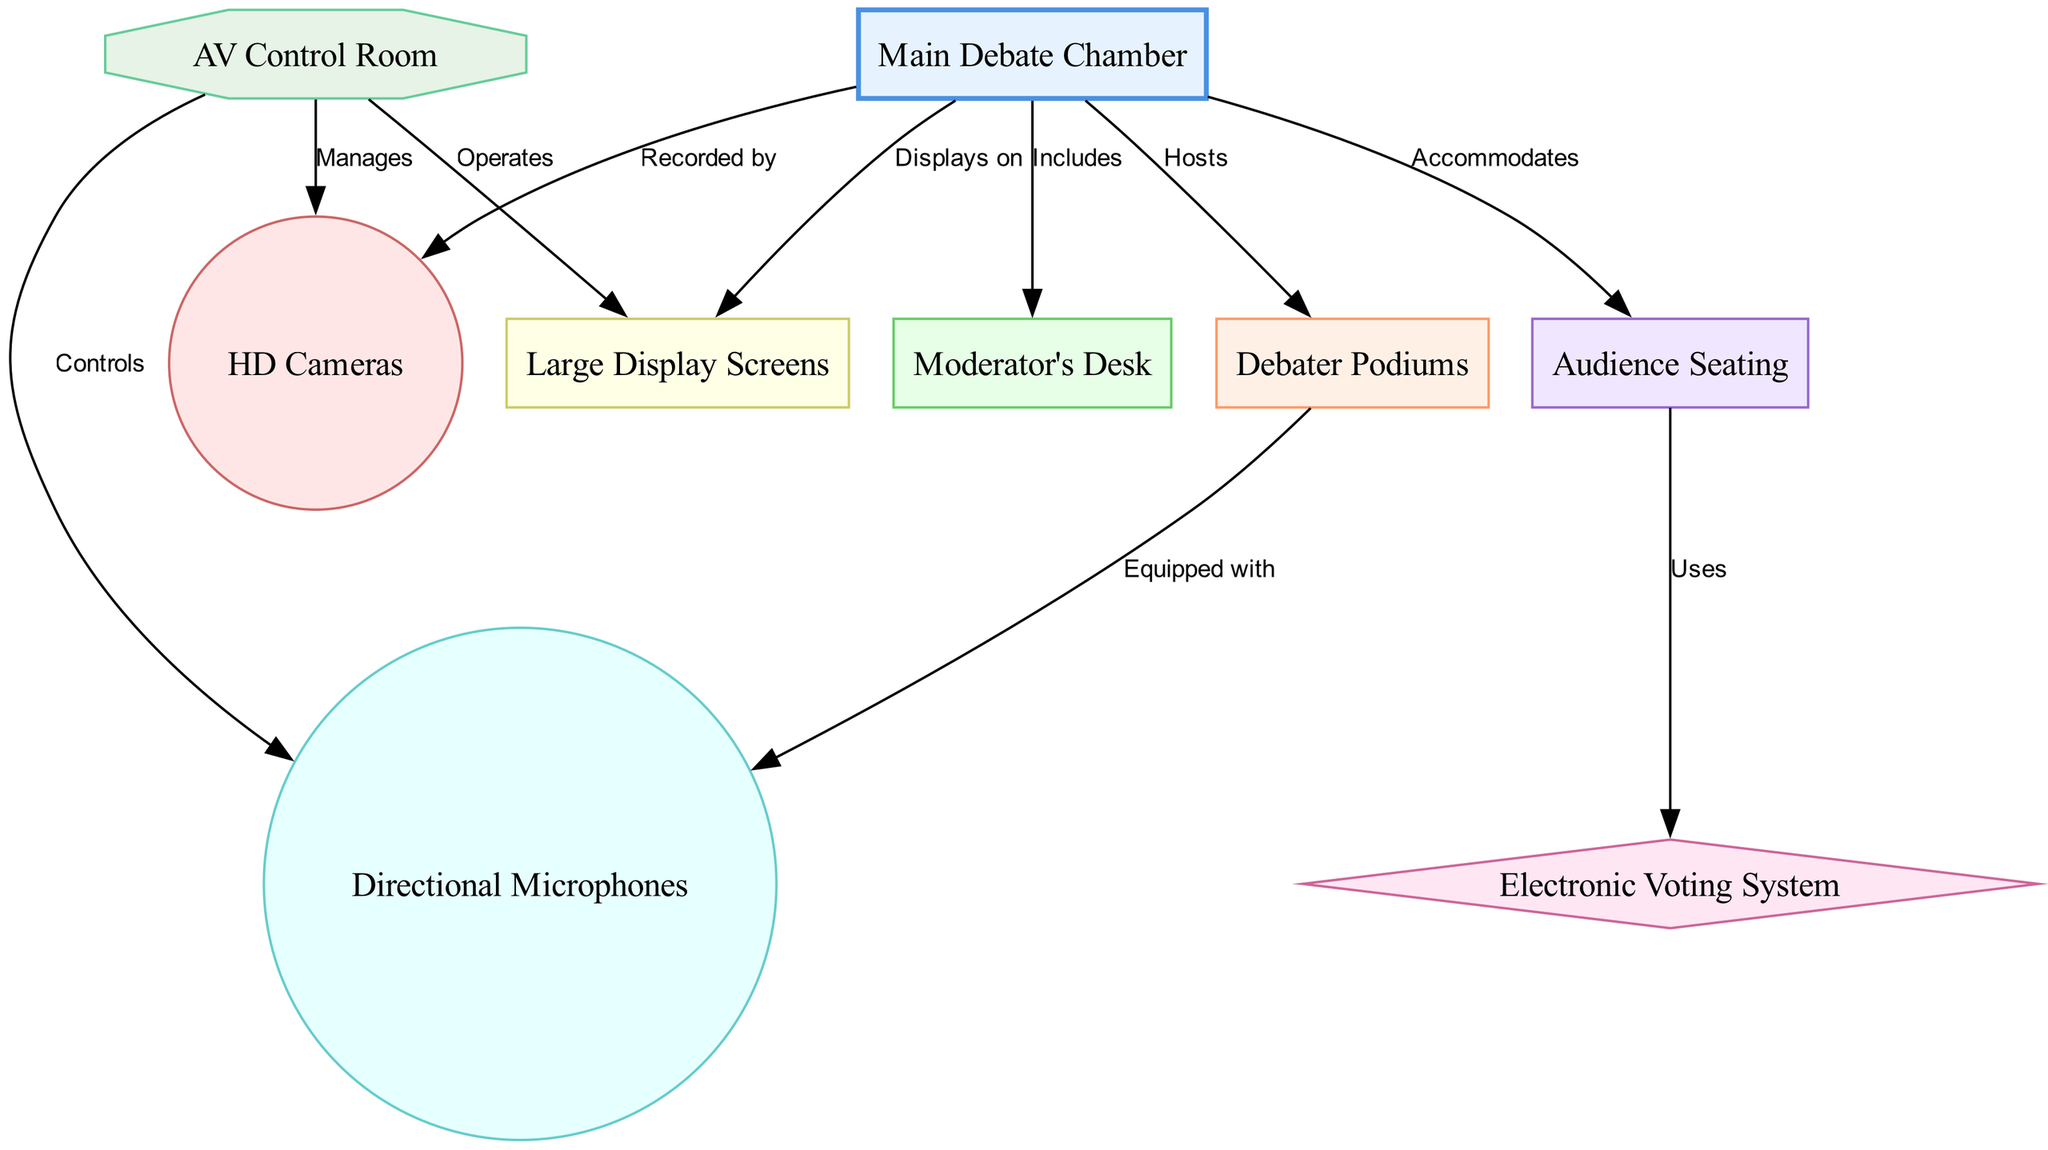What is the main component of the debate chamber? The diagram indicates that the "Main Debate Chamber" serves as the central element around which the other components are organized. Therefore, the main component is identified as "Main Debate Chamber."
Answer: Main Debate Chamber How many types of equipment are mentioned in the diagram? By reviewing the nodes in the diagram, we can count the types of equipment listed, which include "HD Cameras," "Directional Microphones," "Large Display Screens," and "Electronic Voting System." This totals four distinct types of equipment.
Answer: 4 Which area accommodates the audience? The "Audience Seating" is explicitly mentioned to be accommodated within the "Main Debate Chamber," making it the designated area for the audience.
Answer: Audience Seating What does the control room manage? The "AV Control Room" is connected to "HD Cameras," "Directional Microphones," and "Large Display Screens," indicating that it manages all these audiovisual components to facilitate their operation in the debate chamber.
Answer: HD Cameras, Directional Microphones, Large Display Screens Which component uses the audience's votes? The "Electronic Voting System" is shown as being utilized by the audience, highlighting its function in collecting and processing votes during the debate process.
Answer: Electronic Voting System How are debater podiums equipped? According to the diagram, the "Debater Podiums" are specifically described as being equipped with "Directional Microphones." This shows the direct relationship defined by the edge connecting these two nodes.
Answer: Directional Microphones What is recorded by HD cameras in the chamber? The HD Cameras are indicated to be positioned within the "Main Debate Chamber," suggesting that they record the proceedings taking place within this central space during the debates.
Answer: Main Debate Chamber What connects the moderator to the debate chamber? The relationship defined by the edge between the "Moderator's Desk" and the "Main Debate Chamber" emphasizes that the moderator is included within the chamber's structure, highlighting their integral role during the debates.
Answer: Includes Which room operates the audiovisual equipment during the debate? The "AV Control Room" is clearly indicated as the entity that operates the audiovisual equipment, managing the relevant systems to ensure smooth execution throughout the debate.
Answer: AV Control Room 